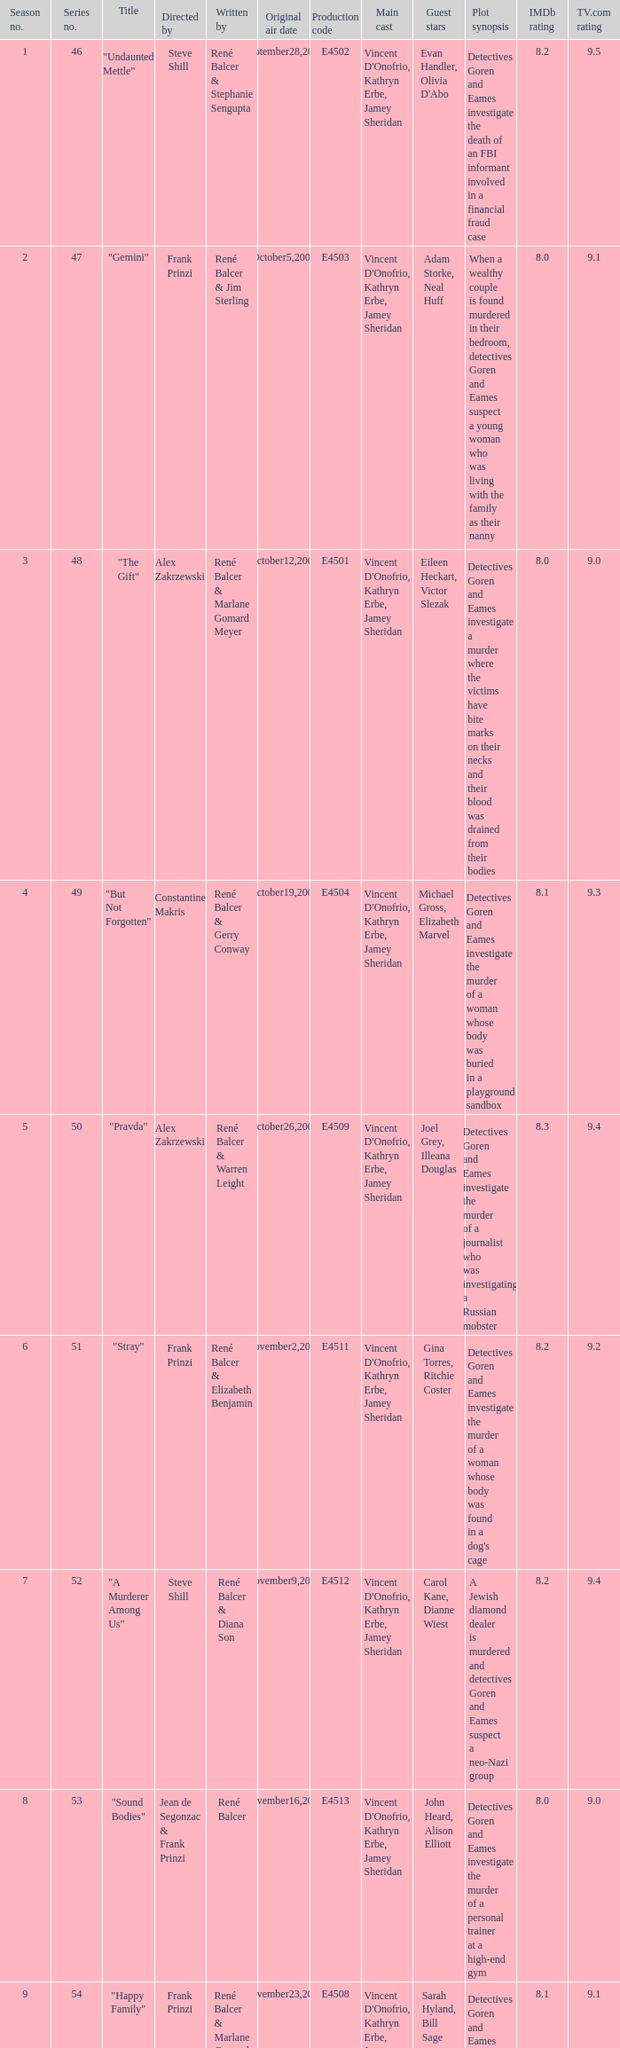What date did "d.a.w." Originally air? May16,2004. 